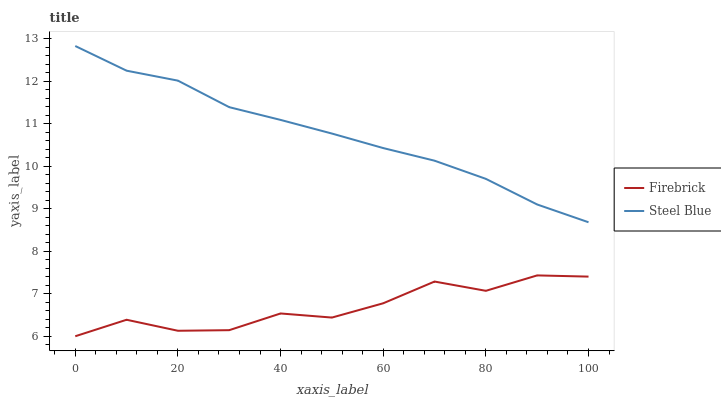Does Firebrick have the minimum area under the curve?
Answer yes or no. Yes. Does Steel Blue have the maximum area under the curve?
Answer yes or no. Yes. Does Steel Blue have the minimum area under the curve?
Answer yes or no. No. Is Steel Blue the smoothest?
Answer yes or no. Yes. Is Firebrick the roughest?
Answer yes or no. Yes. Is Steel Blue the roughest?
Answer yes or no. No. Does Firebrick have the lowest value?
Answer yes or no. Yes. Does Steel Blue have the lowest value?
Answer yes or no. No. Does Steel Blue have the highest value?
Answer yes or no. Yes. Is Firebrick less than Steel Blue?
Answer yes or no. Yes. Is Steel Blue greater than Firebrick?
Answer yes or no. Yes. Does Firebrick intersect Steel Blue?
Answer yes or no. No. 